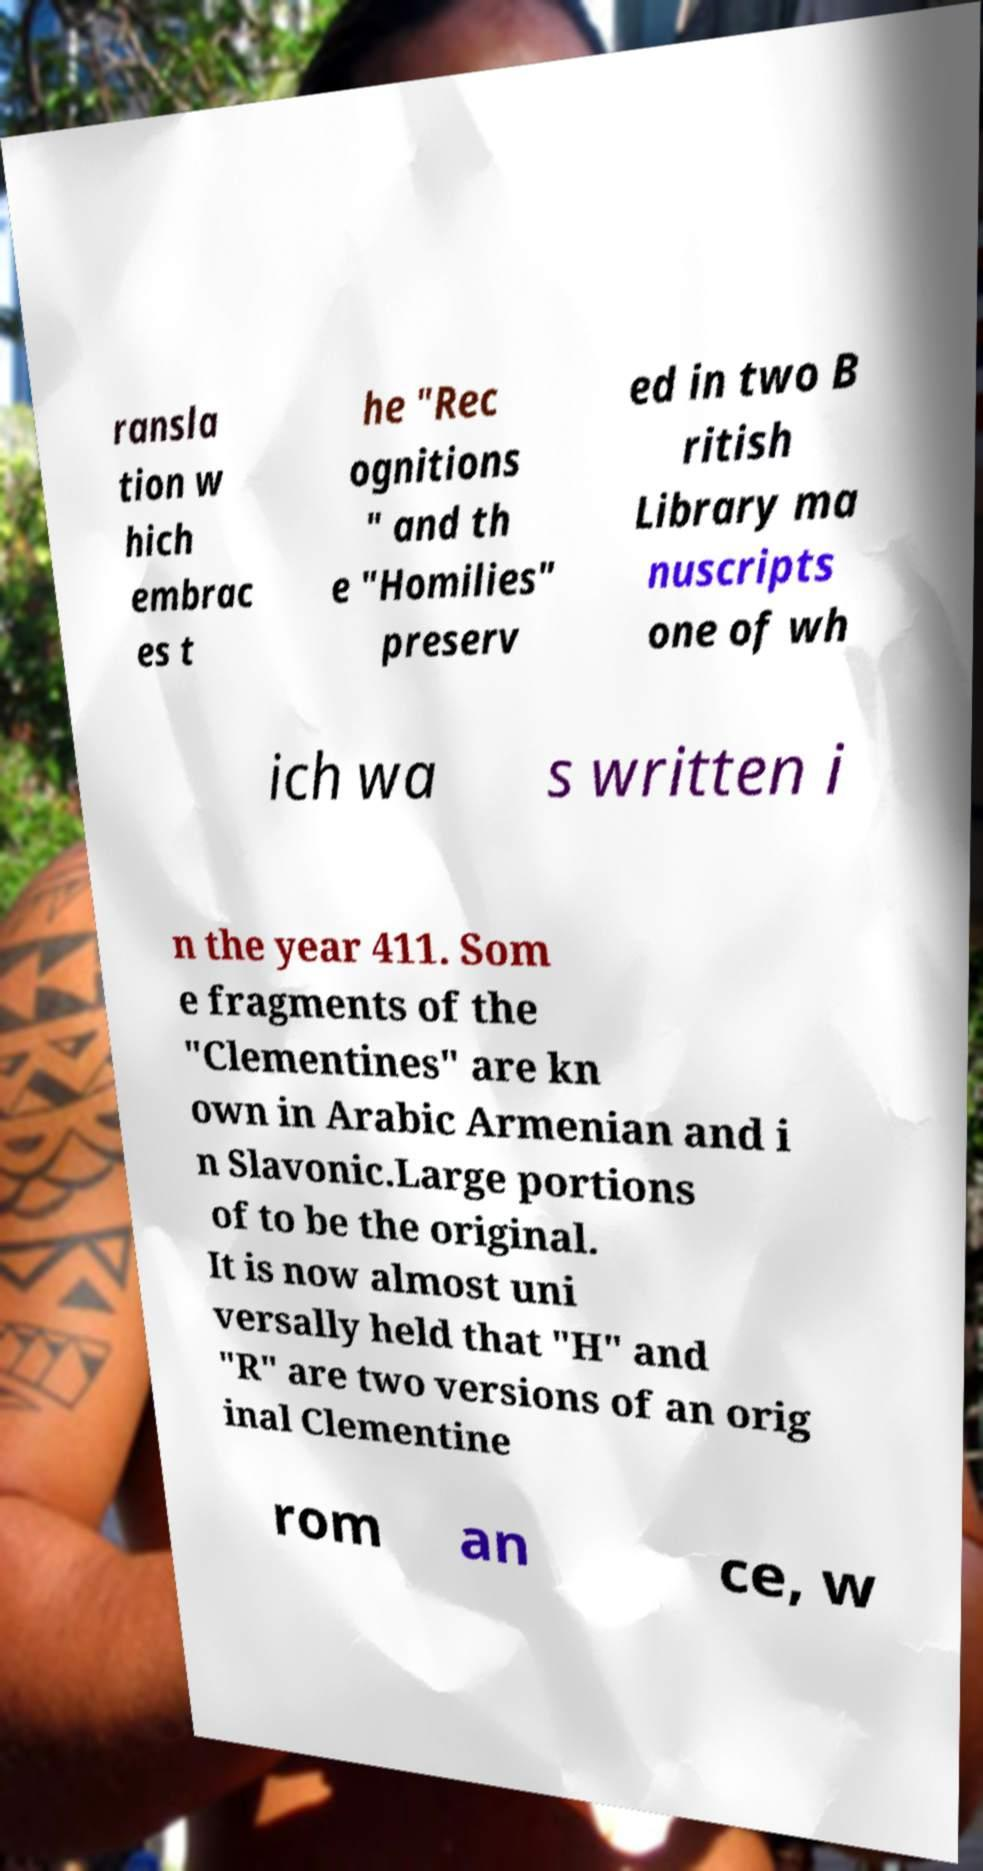Could you extract and type out the text from this image? ransla tion w hich embrac es t he "Rec ognitions " and th e "Homilies" preserv ed in two B ritish Library ma nuscripts one of wh ich wa s written i n the year 411. Som e fragments of the "Clementines" are kn own in Arabic Armenian and i n Slavonic.Large portions of to be the original. It is now almost uni versally held that "H" and "R" are two versions of an orig inal Clementine rom an ce, w 